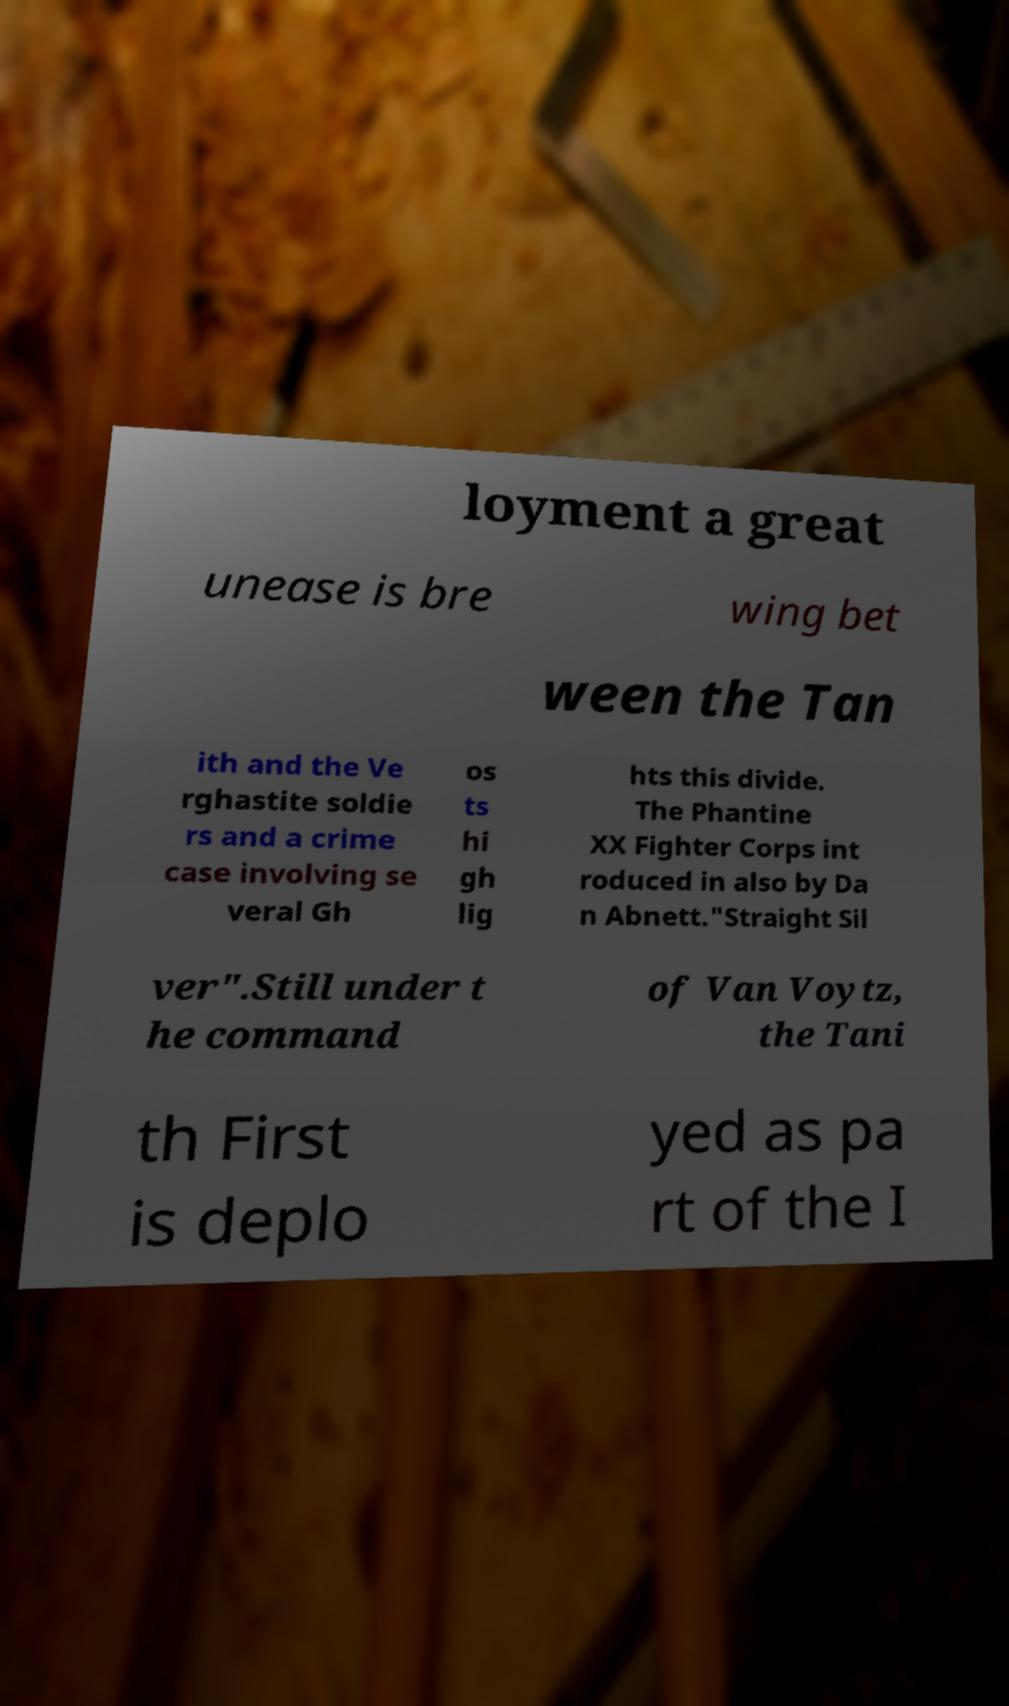Please read and relay the text visible in this image. What does it say? loyment a great unease is bre wing bet ween the Tan ith and the Ve rghastite soldie rs and a crime case involving se veral Gh os ts hi gh lig hts this divide. The Phantine XX Fighter Corps int roduced in also by Da n Abnett."Straight Sil ver".Still under t he command of Van Voytz, the Tani th First is deplo yed as pa rt of the I 